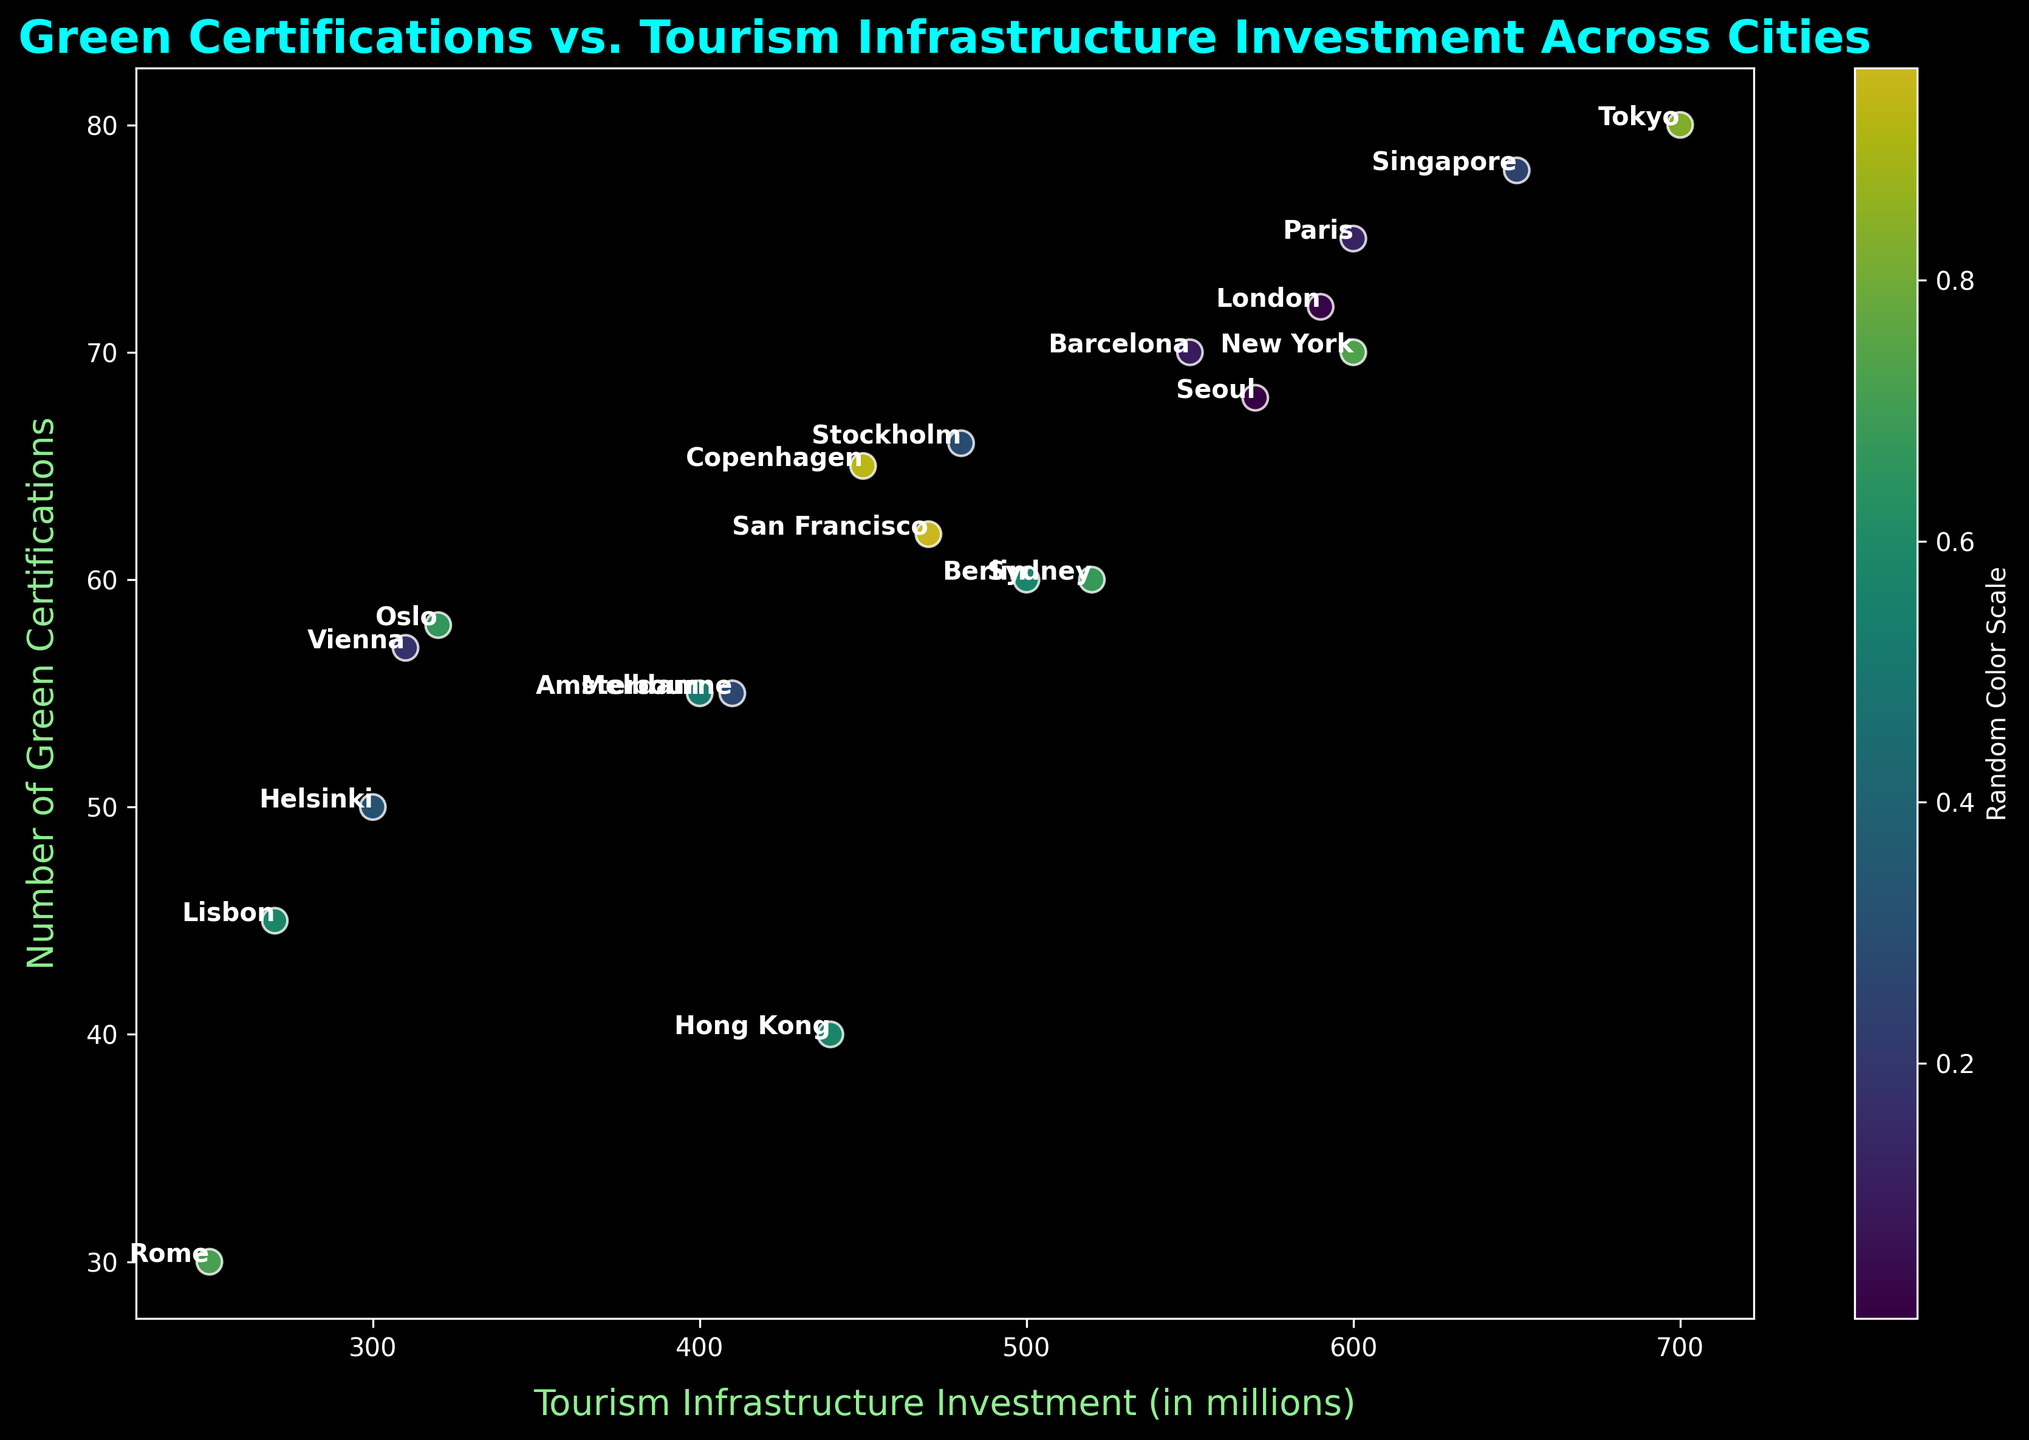What's the city with the highest number of Green Certifications? By visually inspecting the y-axis, the highest point corresponds to Tokyo with 80 Green Certifications
Answer: Tokyo Which city has the lowest tourism infrastructure investment, and how much is that investment? By looking at the x-axis, Rome has the lowest investment at 250 million dollars
Answer: Rome, 250 million dollars Which cities have both Green Certifications and Tourism Infrastructure Investment above the average values of these metrics? To answer, first estimate the average Green Certifications and Tourism Infrastructure Investment, then identify cities above these averages. Average Green Certifications ≈ (sum of all certifications/number of cities) ≈ 60.3, Average Investments ≈ 454 million. Cities above both are Barcelona, London, Paris, Tokyo, and Singapore
Answer: Barcelona, London, Paris, Tokyo, Singapore How does the Green Certification number of Paris compare to that of New York? Comparing the two, Paris has 75 while New York has 70; thus Paris has 5 more Green Certifications than New York
Answer: Paris has 5 more Which cities are positioned to the right of Berlin in terms of Tourism Infrastructure Investment, and how does their number of Green Certifications compare on average? Cities right of Berlin on the x-axis are Barcelona (550), Paris (600), London (590), Tokyo (700), Seoul (570), Sydney (520), Singapore (650). Their Green Certifications: 70, 75, 72, 80, 68, 60, 78 respectively. The average of these certifications is (70 + 75 + 72 + 80 + 68 + 60 + 78) / 7 ≈ 71.86
Answer: Cities: Barcelona, Paris, London, Tokyo, Seoul, Sydney, Singapore. Average Certifications: ≈ 71.86 What is the difference in Green Certifications between the cities with the highest and lowest tourism infrastructure investment? Highest investment: Tokyo (700 million) with 80 certifications. Lowest investment: Rome (250 million) with 30 certifications. Difference = 80 - 30 = 50
Answer: 50 Compare the Tourism Infrastructure Investment for both Amsterdam and Melbourne. Which city invests more and by how much? Amsterdam invests 400 million and Melbourne invests 410 million. The difference is 410 - 400 = 10 million; thus, Melbourne invests 10 million more
Answer: Melbourne by 10 million How does the number of Green Certifications of Singapore compare to that of Berlin visually? From the plot, Singapore has 78 certifications while Berlin has 60. Singapore has 18 more certifications
Answer: Singapore has 18 more Identify the city with the closest number of Green Certifications to Stockholm and state the exact difference. Stockholm has 66 certifications. The closest city is Copenhagen with 65 certifications. The difference is 66 - 65 = 1
Answer: Copenhagen, 1 